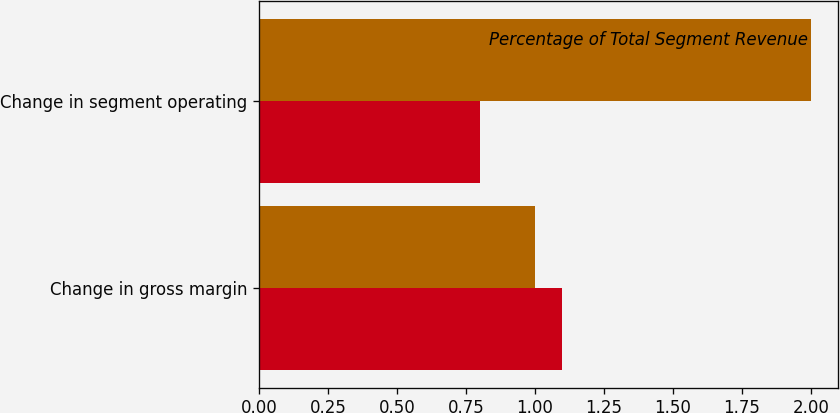Convert chart. <chart><loc_0><loc_0><loc_500><loc_500><stacked_bar_chart><ecel><fcel>Change in gross margin<fcel>Change in segment operating<nl><fcel>nan<fcel>1.1<fcel>0.8<nl><fcel>Percentage of Total Segment Revenue<fcel>1<fcel>2<nl></chart> 